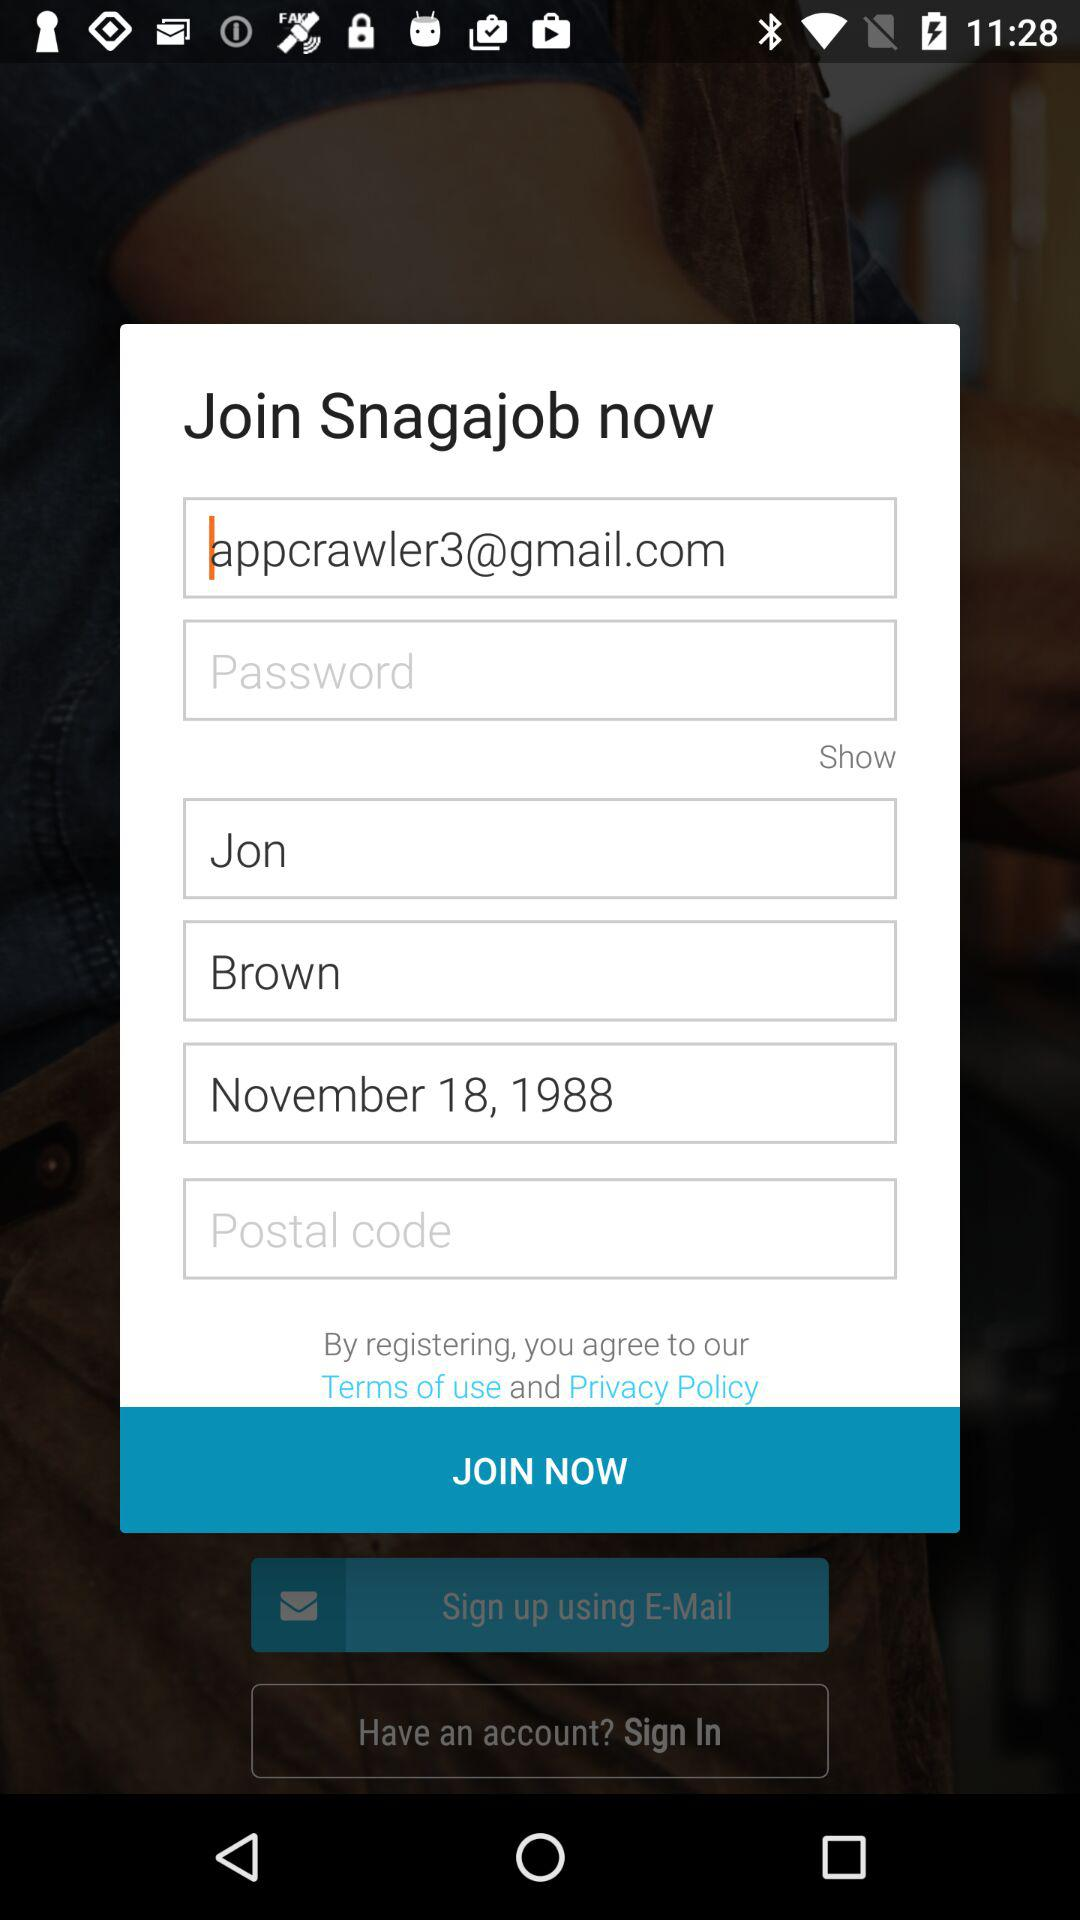What email address is used for sign-in? The email address used for sign-in is appcrawler3@gmail.com. 